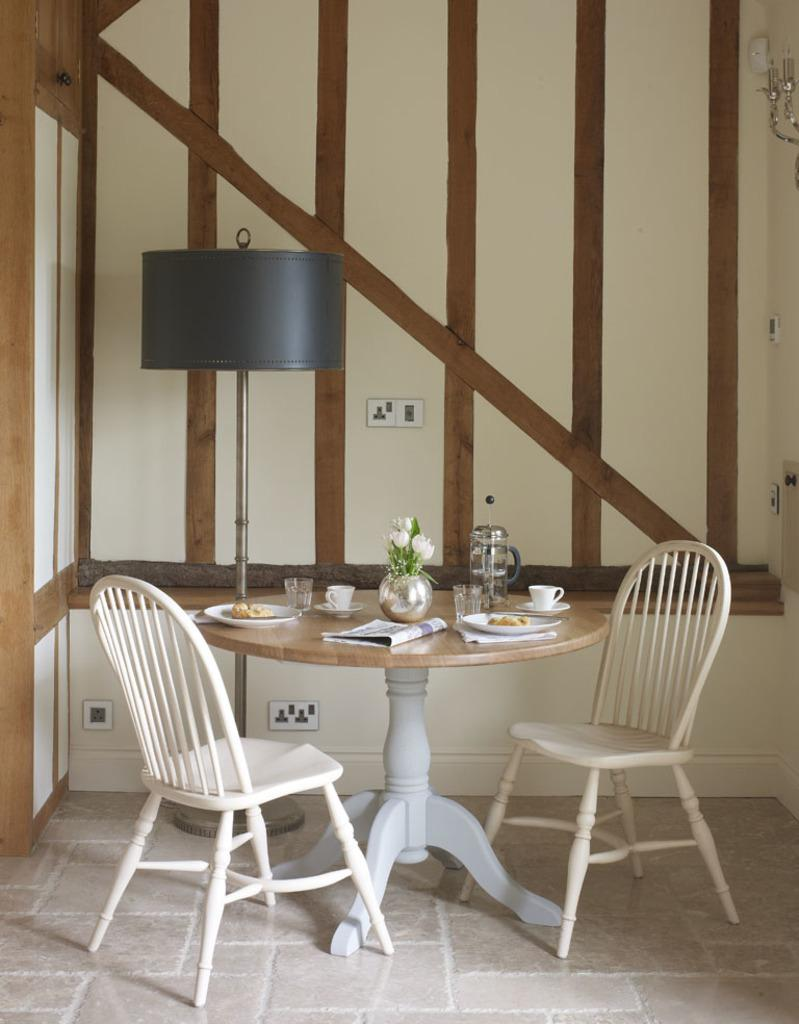What type of furniture is present in the image? There is a table in the image, and chairs are on the floor. What items can be seen on the table? There are plates, cups, a newspaper, and a flower vase on the table. Is there any source of light visible in the image? Yes, there is a lamp in the image. What can be seen in the background of the image? A wall is visible in the image. How many planes are flying in the image? There are no planes visible in the image. What is the chance of winning a prize in the image? There is no mention of a prize or any game of chance in the image. 